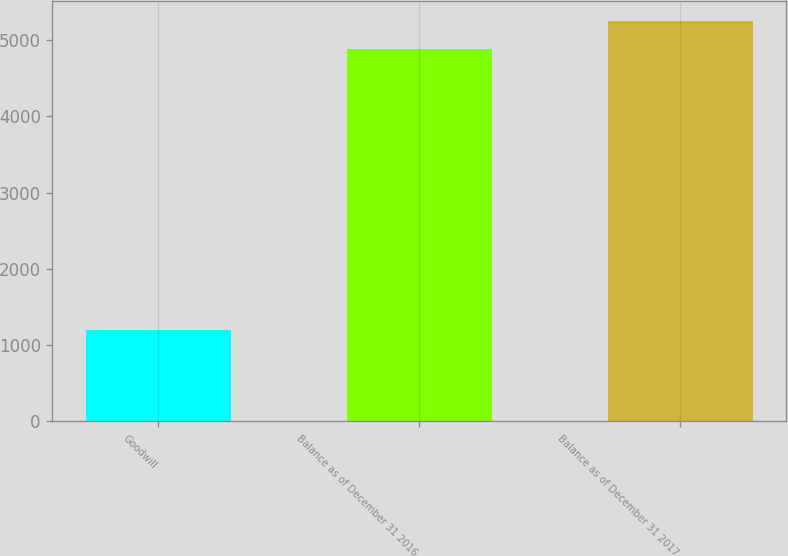<chart> <loc_0><loc_0><loc_500><loc_500><bar_chart><fcel>Goodwill<fcel>Balance as of December 31 2016<fcel>Balance as of December 31 2017<nl><fcel>1194<fcel>4883<fcel>5251.9<nl></chart> 